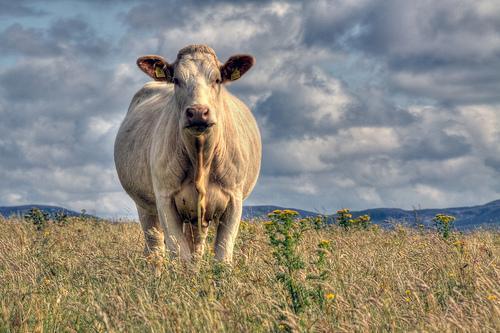How many animals are there?
Give a very brief answer. 1. 